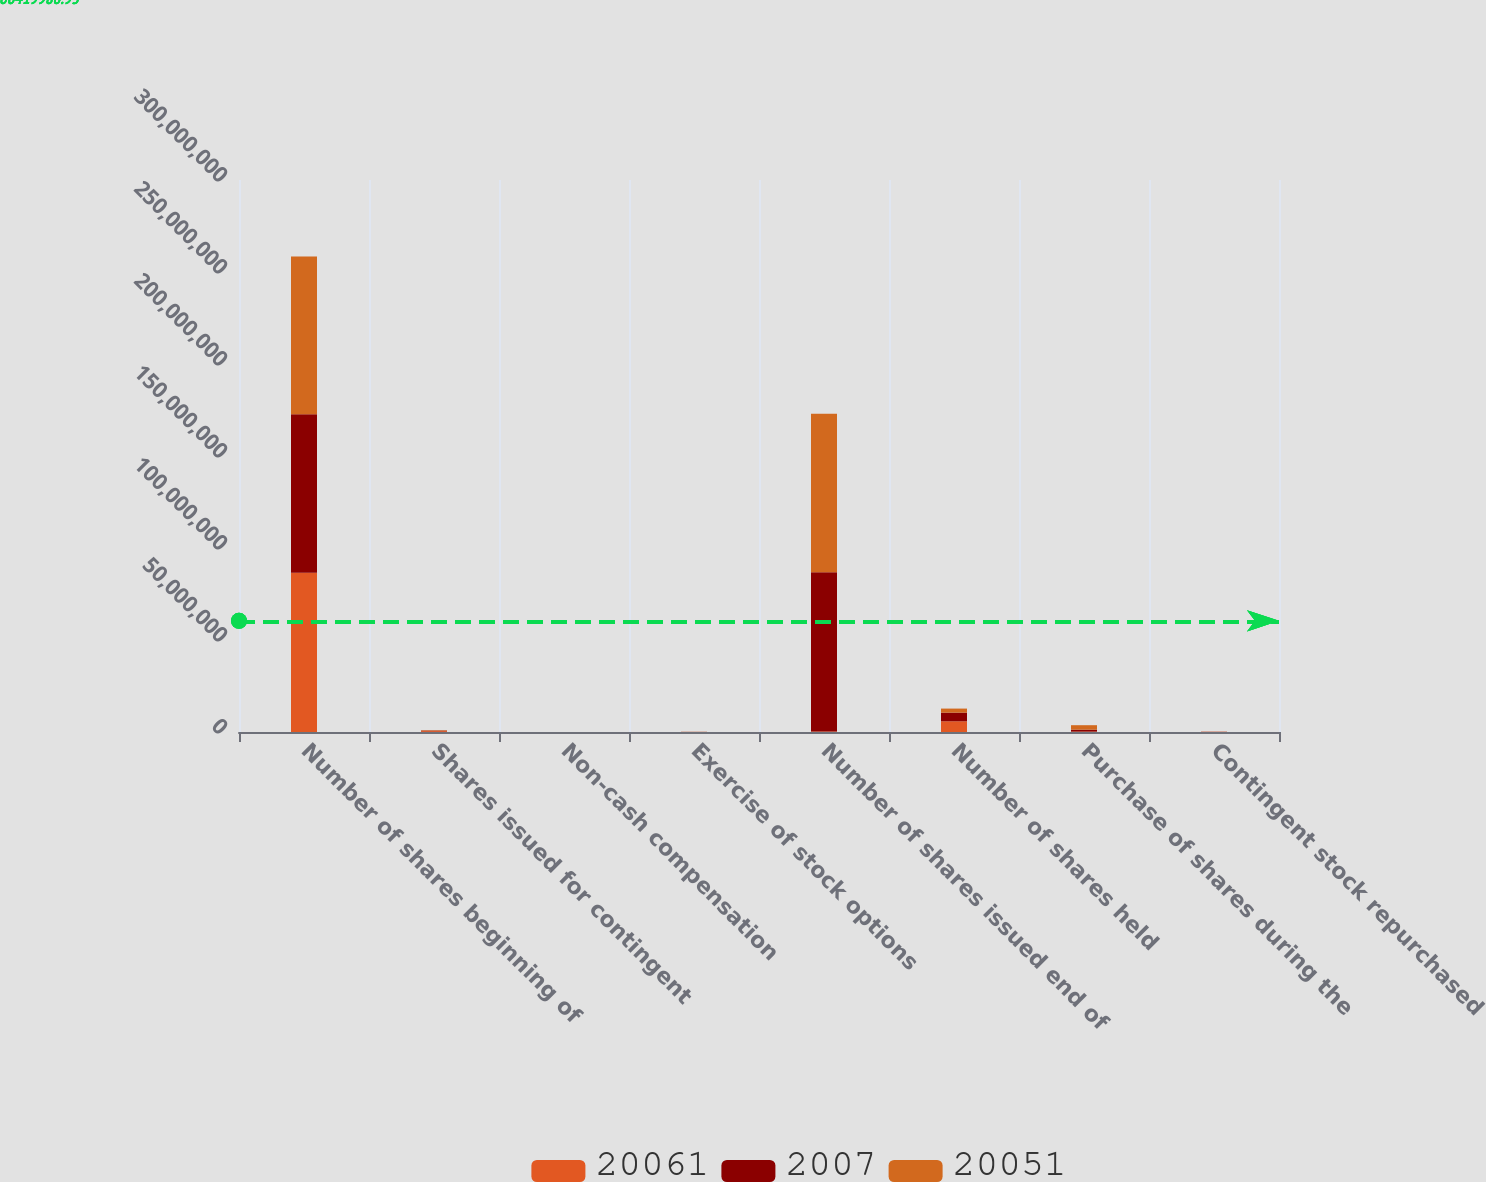Convert chart to OTSL. <chart><loc_0><loc_0><loc_500><loc_500><stacked_bar_chart><ecel><fcel>Number of shares beginning of<fcel>Shares issued for contingent<fcel>Non-cash compensation<fcel>Exercise of stock options<fcel>Number of shares issued end of<fcel>Number of shares held<fcel>Purchase of shares during the<fcel>Contingent stock repurchased<nl><fcel>20061<fcel>8.64889e+07<fcel>474100<fcel>6762<fcel>15693<fcel>271350<fcel>5.82388e+06<fcel>216000<fcel>74806<nl><fcel>2007<fcel>8.61427e+07<fcel>271350<fcel>4983<fcel>69839<fcel>8.64889e+07<fcel>4.69109e+06<fcel>1.0492e+06<fcel>83599<nl><fcel>20051<fcel>8.58361e+07<fcel>241200<fcel>1743<fcel>63696<fcel>8.61427e+07<fcel>2.21189e+06<fcel>2.4302e+06<fcel>49000<nl></chart> 